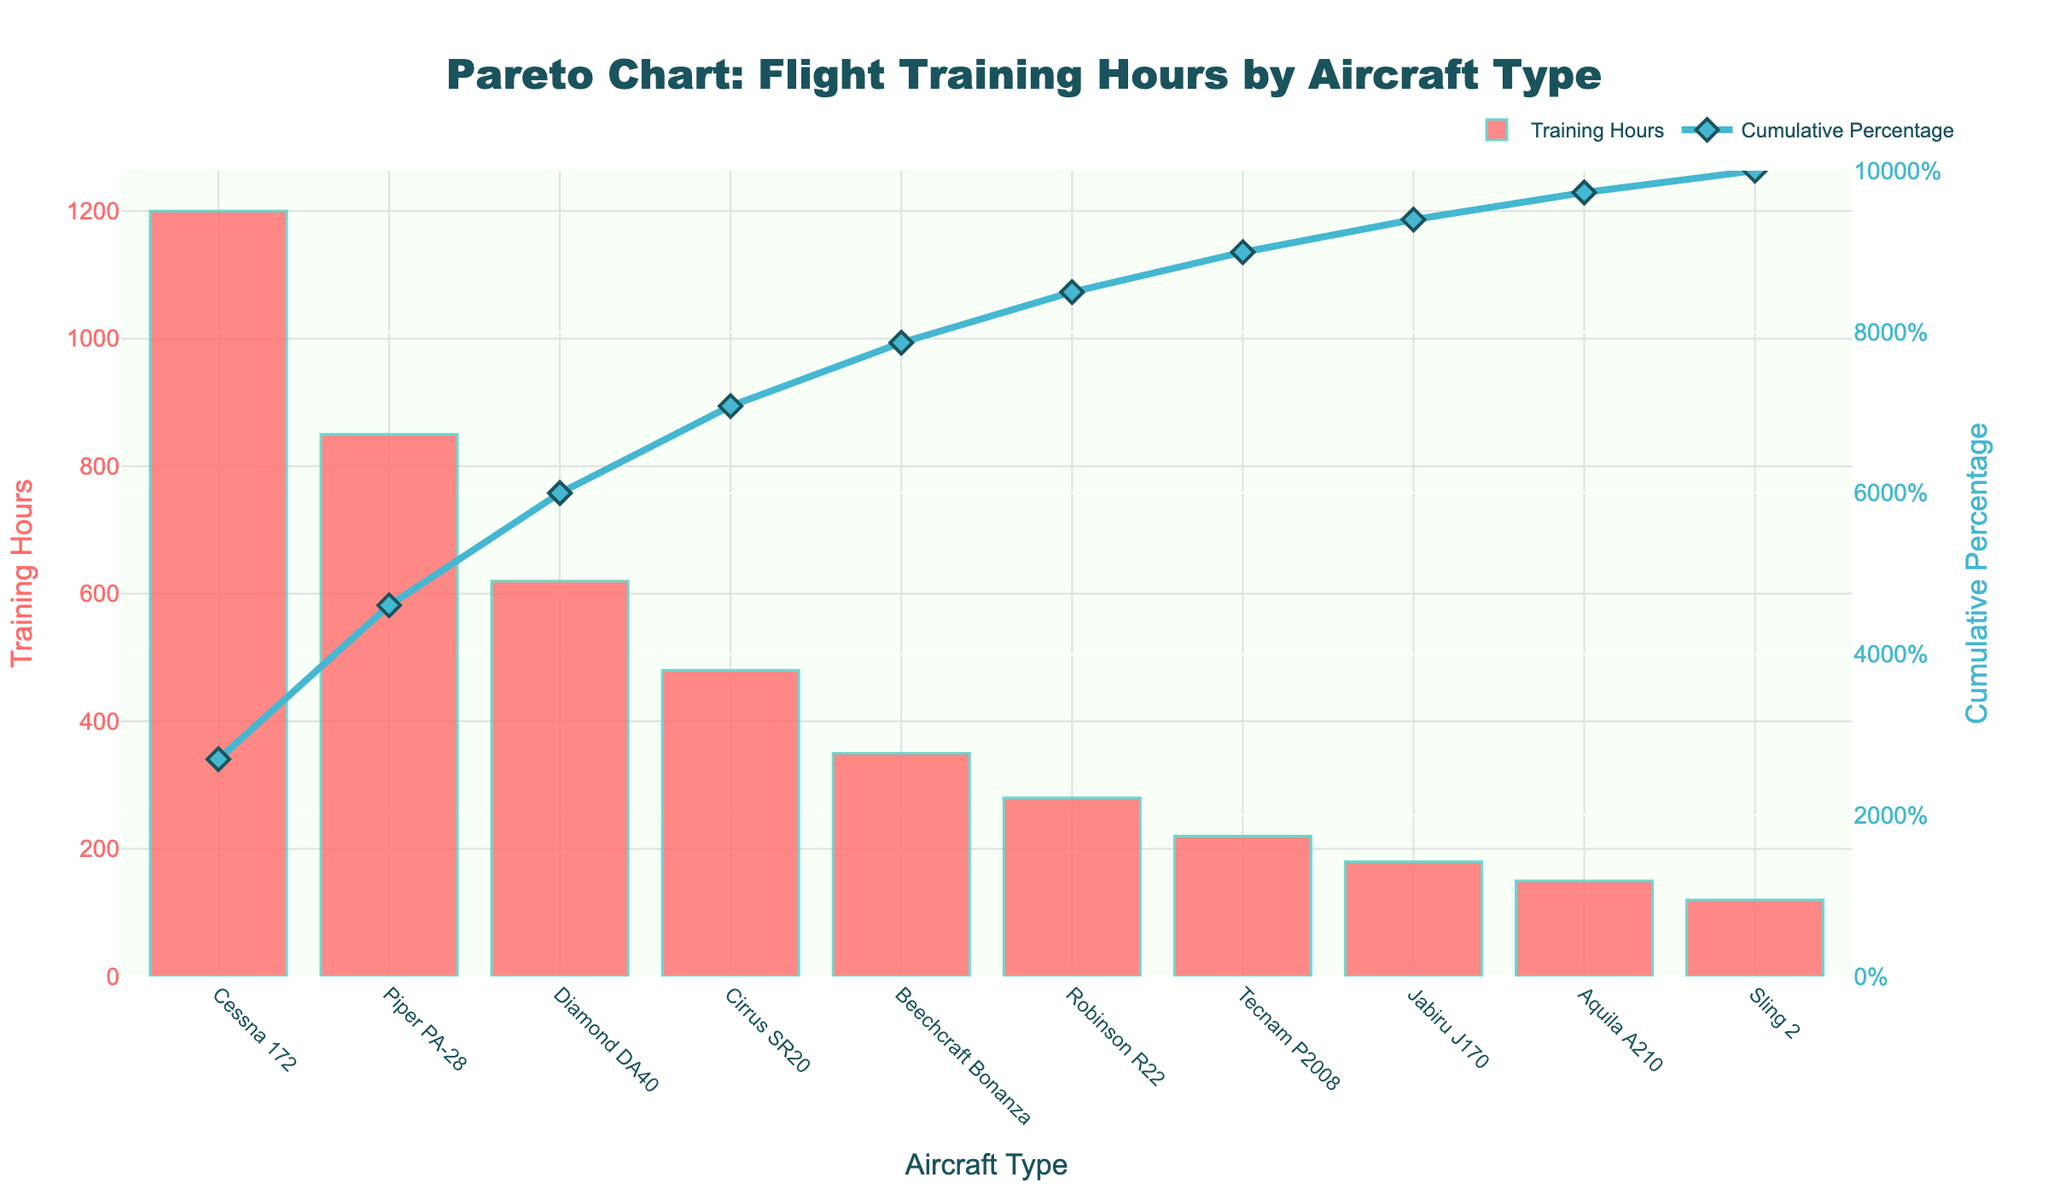what is the title of the figure? The title is displayed at the top of the figure, typically centered. It clearly states what the Pareto chart represents.
Answer: Pareto Chart: Flight Training Hours by Aircraft Type How many aircraft types are displayed on the X-axis? The X-axis displays different aircraft types. Counting each label will give the number of aircraft types.
Answer: 10 Which aircraft type has the highest number of training hours? The highest bar in the chart corresponds to the aircraft type with the most training hours. The highest bar has the label "Cessna 172".
Answer: Cessna 172 What is the cumulative percentage after including the Piper PA-28? To find the cumulative percentage, look at the line chart portion of the Pareto chart where the Piper PA-28 is plotted. The corresponding percentage value shows the answer.
Answer: 68.5% What is the color of the bars representing training hours? The color of the bars can be observed directly from the chart. It is specified as part of the visual appearance.
Answer: Red with turquoise outline What is the range of the cumulative percentage axis? Observe the right Y-axis which represents the cumulative percentage. The given range will help identify it.
Answer: 0% to 100% What are the training hours for the least used aircraft type? The lowest bar on the chart indicates the aircraft type with the least number of training hours. It corresponds to the label "Sling 2".
Answer: 120 hours Which three aircraft types have training hours contributing to more than 50% cumulative percentage? Find the point where the cumulative percentage line exceeds 50%. Identify the aircraft types up to this point from the bar chart section.
Answer: Cessna 172, Piper PA-28, Diamond DA40 How many training hours are completed by Tecnam P2008 and Jabiru J170 combined? Add the training hours for Tecnam P2008 (220) and Jabiru J170 (180). The combination gives the total hours.
Answer: 400 hours Which aircraft type achieved between 50% and 68.5% cumulative percentage? Identify the aircraft types where the cumulative percentage moves from 50% (inclusive) to 68.5% (exclusive). This is derived from the line chart.
Answer: Piper PA-28 